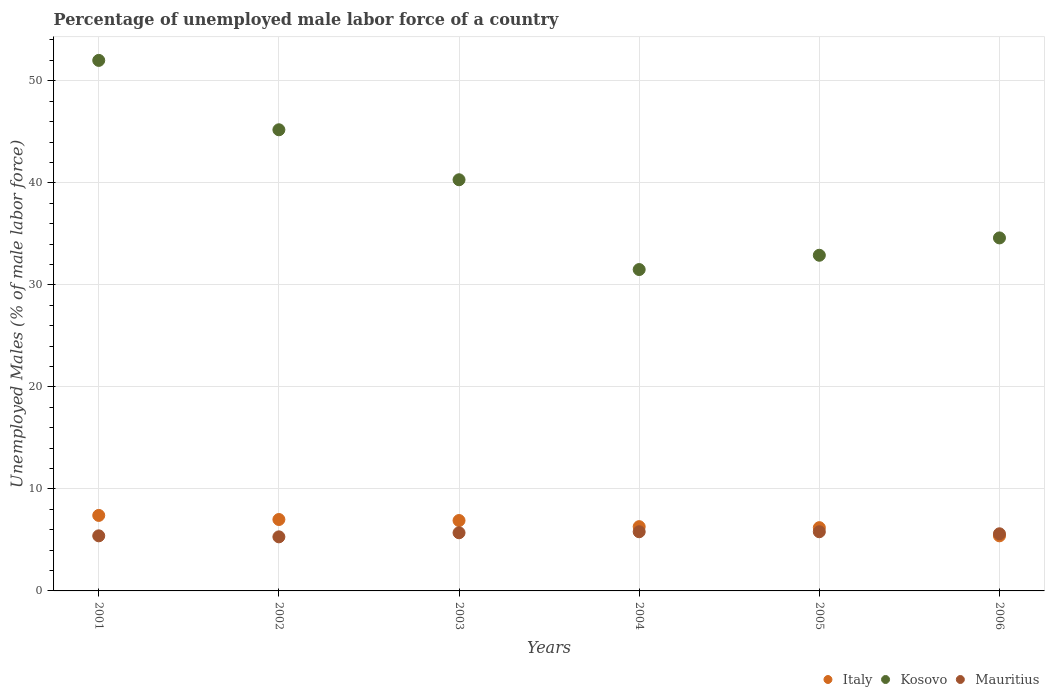How many different coloured dotlines are there?
Your answer should be compact. 3. Is the number of dotlines equal to the number of legend labels?
Make the answer very short. Yes. What is the percentage of unemployed male labor force in Italy in 2006?
Provide a short and direct response. 5.4. Across all years, what is the maximum percentage of unemployed male labor force in Mauritius?
Offer a very short reply. 5.8. Across all years, what is the minimum percentage of unemployed male labor force in Italy?
Provide a succinct answer. 5.4. What is the total percentage of unemployed male labor force in Italy in the graph?
Provide a succinct answer. 39.2. What is the difference between the percentage of unemployed male labor force in Italy in 2002 and that in 2005?
Offer a very short reply. 0.8. What is the difference between the percentage of unemployed male labor force in Kosovo in 2003 and the percentage of unemployed male labor force in Italy in 2005?
Ensure brevity in your answer.  34.1. What is the average percentage of unemployed male labor force in Kosovo per year?
Provide a succinct answer. 39.42. In the year 2005, what is the difference between the percentage of unemployed male labor force in Mauritius and percentage of unemployed male labor force in Kosovo?
Offer a terse response. -27.1. What is the ratio of the percentage of unemployed male labor force in Mauritius in 2001 to that in 2002?
Make the answer very short. 1.02. Is the percentage of unemployed male labor force in Mauritius in 2001 less than that in 2004?
Give a very brief answer. Yes. What is the difference between the highest and the second highest percentage of unemployed male labor force in Italy?
Your answer should be compact. 0.4. What is the difference between the highest and the lowest percentage of unemployed male labor force in Mauritius?
Keep it short and to the point. 0.5. Is it the case that in every year, the sum of the percentage of unemployed male labor force in Mauritius and percentage of unemployed male labor force in Italy  is greater than the percentage of unemployed male labor force in Kosovo?
Your response must be concise. No. Does the percentage of unemployed male labor force in Kosovo monotonically increase over the years?
Offer a terse response. No. How many dotlines are there?
Your answer should be compact. 3. What is the difference between two consecutive major ticks on the Y-axis?
Ensure brevity in your answer.  10. Does the graph contain any zero values?
Offer a very short reply. No. How many legend labels are there?
Offer a very short reply. 3. What is the title of the graph?
Ensure brevity in your answer.  Percentage of unemployed male labor force of a country. Does "Faeroe Islands" appear as one of the legend labels in the graph?
Keep it short and to the point. No. What is the label or title of the Y-axis?
Ensure brevity in your answer.  Unemployed Males (% of male labor force). What is the Unemployed Males (% of male labor force) in Italy in 2001?
Offer a terse response. 7.4. What is the Unemployed Males (% of male labor force) of Mauritius in 2001?
Offer a terse response. 5.4. What is the Unemployed Males (% of male labor force) of Kosovo in 2002?
Provide a short and direct response. 45.2. What is the Unemployed Males (% of male labor force) of Mauritius in 2002?
Provide a succinct answer. 5.3. What is the Unemployed Males (% of male labor force) of Italy in 2003?
Keep it short and to the point. 6.9. What is the Unemployed Males (% of male labor force) in Kosovo in 2003?
Offer a very short reply. 40.3. What is the Unemployed Males (% of male labor force) of Mauritius in 2003?
Offer a terse response. 5.7. What is the Unemployed Males (% of male labor force) in Italy in 2004?
Provide a succinct answer. 6.3. What is the Unemployed Males (% of male labor force) of Kosovo in 2004?
Offer a very short reply. 31.5. What is the Unemployed Males (% of male labor force) in Mauritius in 2004?
Offer a very short reply. 5.8. What is the Unemployed Males (% of male labor force) in Italy in 2005?
Offer a terse response. 6.2. What is the Unemployed Males (% of male labor force) of Kosovo in 2005?
Provide a succinct answer. 32.9. What is the Unemployed Males (% of male labor force) in Mauritius in 2005?
Your answer should be very brief. 5.8. What is the Unemployed Males (% of male labor force) of Italy in 2006?
Make the answer very short. 5.4. What is the Unemployed Males (% of male labor force) in Kosovo in 2006?
Ensure brevity in your answer.  34.6. What is the Unemployed Males (% of male labor force) in Mauritius in 2006?
Give a very brief answer. 5.6. Across all years, what is the maximum Unemployed Males (% of male labor force) in Italy?
Offer a very short reply. 7.4. Across all years, what is the maximum Unemployed Males (% of male labor force) of Kosovo?
Your answer should be very brief. 52. Across all years, what is the maximum Unemployed Males (% of male labor force) in Mauritius?
Offer a very short reply. 5.8. Across all years, what is the minimum Unemployed Males (% of male labor force) of Italy?
Keep it short and to the point. 5.4. Across all years, what is the minimum Unemployed Males (% of male labor force) of Kosovo?
Your response must be concise. 31.5. Across all years, what is the minimum Unemployed Males (% of male labor force) in Mauritius?
Keep it short and to the point. 5.3. What is the total Unemployed Males (% of male labor force) of Italy in the graph?
Ensure brevity in your answer.  39.2. What is the total Unemployed Males (% of male labor force) of Kosovo in the graph?
Provide a short and direct response. 236.5. What is the total Unemployed Males (% of male labor force) of Mauritius in the graph?
Provide a succinct answer. 33.6. What is the difference between the Unemployed Males (% of male labor force) in Kosovo in 2001 and that in 2002?
Provide a short and direct response. 6.8. What is the difference between the Unemployed Males (% of male labor force) of Kosovo in 2001 and that in 2003?
Offer a terse response. 11.7. What is the difference between the Unemployed Males (% of male labor force) in Mauritius in 2001 and that in 2003?
Ensure brevity in your answer.  -0.3. What is the difference between the Unemployed Males (% of male labor force) of Italy in 2001 and that in 2004?
Make the answer very short. 1.1. What is the difference between the Unemployed Males (% of male labor force) of Kosovo in 2001 and that in 2004?
Provide a short and direct response. 20.5. What is the difference between the Unemployed Males (% of male labor force) of Mauritius in 2001 and that in 2004?
Your answer should be very brief. -0.4. What is the difference between the Unemployed Males (% of male labor force) of Kosovo in 2001 and that in 2005?
Your answer should be compact. 19.1. What is the difference between the Unemployed Males (% of male labor force) of Mauritius in 2001 and that in 2006?
Provide a short and direct response. -0.2. What is the difference between the Unemployed Males (% of male labor force) of Kosovo in 2002 and that in 2003?
Provide a succinct answer. 4.9. What is the difference between the Unemployed Males (% of male labor force) in Mauritius in 2002 and that in 2003?
Give a very brief answer. -0.4. What is the difference between the Unemployed Males (% of male labor force) in Italy in 2002 and that in 2004?
Give a very brief answer. 0.7. What is the difference between the Unemployed Males (% of male labor force) in Kosovo in 2002 and that in 2004?
Keep it short and to the point. 13.7. What is the difference between the Unemployed Males (% of male labor force) in Italy in 2002 and that in 2005?
Offer a terse response. 0.8. What is the difference between the Unemployed Males (% of male labor force) in Kosovo in 2002 and that in 2006?
Ensure brevity in your answer.  10.6. What is the difference between the Unemployed Males (% of male labor force) in Mauritius in 2002 and that in 2006?
Offer a very short reply. -0.3. What is the difference between the Unemployed Males (% of male labor force) of Kosovo in 2003 and that in 2004?
Offer a very short reply. 8.8. What is the difference between the Unemployed Males (% of male labor force) of Mauritius in 2003 and that in 2004?
Your answer should be compact. -0.1. What is the difference between the Unemployed Males (% of male labor force) in Mauritius in 2003 and that in 2005?
Offer a very short reply. -0.1. What is the difference between the Unemployed Males (% of male labor force) of Italy in 2003 and that in 2006?
Provide a short and direct response. 1.5. What is the difference between the Unemployed Males (% of male labor force) in Italy in 2004 and that in 2005?
Offer a very short reply. 0.1. What is the difference between the Unemployed Males (% of male labor force) in Mauritius in 2004 and that in 2005?
Your response must be concise. 0. What is the difference between the Unemployed Males (% of male labor force) in Italy in 2004 and that in 2006?
Your answer should be compact. 0.9. What is the difference between the Unemployed Males (% of male labor force) in Mauritius in 2004 and that in 2006?
Keep it short and to the point. 0.2. What is the difference between the Unemployed Males (% of male labor force) in Italy in 2001 and the Unemployed Males (% of male labor force) in Kosovo in 2002?
Your answer should be very brief. -37.8. What is the difference between the Unemployed Males (% of male labor force) in Italy in 2001 and the Unemployed Males (% of male labor force) in Mauritius in 2002?
Offer a very short reply. 2.1. What is the difference between the Unemployed Males (% of male labor force) of Kosovo in 2001 and the Unemployed Males (% of male labor force) of Mauritius in 2002?
Offer a terse response. 46.7. What is the difference between the Unemployed Males (% of male labor force) in Italy in 2001 and the Unemployed Males (% of male labor force) in Kosovo in 2003?
Your answer should be compact. -32.9. What is the difference between the Unemployed Males (% of male labor force) in Italy in 2001 and the Unemployed Males (% of male labor force) in Mauritius in 2003?
Give a very brief answer. 1.7. What is the difference between the Unemployed Males (% of male labor force) of Kosovo in 2001 and the Unemployed Males (% of male labor force) of Mauritius in 2003?
Offer a terse response. 46.3. What is the difference between the Unemployed Males (% of male labor force) in Italy in 2001 and the Unemployed Males (% of male labor force) in Kosovo in 2004?
Give a very brief answer. -24.1. What is the difference between the Unemployed Males (% of male labor force) of Italy in 2001 and the Unemployed Males (% of male labor force) of Mauritius in 2004?
Offer a terse response. 1.6. What is the difference between the Unemployed Males (% of male labor force) in Kosovo in 2001 and the Unemployed Males (% of male labor force) in Mauritius in 2004?
Offer a terse response. 46.2. What is the difference between the Unemployed Males (% of male labor force) in Italy in 2001 and the Unemployed Males (% of male labor force) in Kosovo in 2005?
Provide a succinct answer. -25.5. What is the difference between the Unemployed Males (% of male labor force) of Italy in 2001 and the Unemployed Males (% of male labor force) of Mauritius in 2005?
Provide a short and direct response. 1.6. What is the difference between the Unemployed Males (% of male labor force) in Kosovo in 2001 and the Unemployed Males (% of male labor force) in Mauritius in 2005?
Provide a short and direct response. 46.2. What is the difference between the Unemployed Males (% of male labor force) in Italy in 2001 and the Unemployed Males (% of male labor force) in Kosovo in 2006?
Offer a terse response. -27.2. What is the difference between the Unemployed Males (% of male labor force) of Italy in 2001 and the Unemployed Males (% of male labor force) of Mauritius in 2006?
Your answer should be very brief. 1.8. What is the difference between the Unemployed Males (% of male labor force) in Kosovo in 2001 and the Unemployed Males (% of male labor force) in Mauritius in 2006?
Keep it short and to the point. 46.4. What is the difference between the Unemployed Males (% of male labor force) of Italy in 2002 and the Unemployed Males (% of male labor force) of Kosovo in 2003?
Your answer should be compact. -33.3. What is the difference between the Unemployed Males (% of male labor force) of Kosovo in 2002 and the Unemployed Males (% of male labor force) of Mauritius in 2003?
Ensure brevity in your answer.  39.5. What is the difference between the Unemployed Males (% of male labor force) in Italy in 2002 and the Unemployed Males (% of male labor force) in Kosovo in 2004?
Offer a terse response. -24.5. What is the difference between the Unemployed Males (% of male labor force) in Italy in 2002 and the Unemployed Males (% of male labor force) in Mauritius in 2004?
Your response must be concise. 1.2. What is the difference between the Unemployed Males (% of male labor force) of Kosovo in 2002 and the Unemployed Males (% of male labor force) of Mauritius in 2004?
Your answer should be compact. 39.4. What is the difference between the Unemployed Males (% of male labor force) of Italy in 2002 and the Unemployed Males (% of male labor force) of Kosovo in 2005?
Keep it short and to the point. -25.9. What is the difference between the Unemployed Males (% of male labor force) in Italy in 2002 and the Unemployed Males (% of male labor force) in Mauritius in 2005?
Keep it short and to the point. 1.2. What is the difference between the Unemployed Males (% of male labor force) of Kosovo in 2002 and the Unemployed Males (% of male labor force) of Mauritius in 2005?
Your response must be concise. 39.4. What is the difference between the Unemployed Males (% of male labor force) of Italy in 2002 and the Unemployed Males (% of male labor force) of Kosovo in 2006?
Keep it short and to the point. -27.6. What is the difference between the Unemployed Males (% of male labor force) in Italy in 2002 and the Unemployed Males (% of male labor force) in Mauritius in 2006?
Your answer should be very brief. 1.4. What is the difference between the Unemployed Males (% of male labor force) of Kosovo in 2002 and the Unemployed Males (% of male labor force) of Mauritius in 2006?
Offer a very short reply. 39.6. What is the difference between the Unemployed Males (% of male labor force) of Italy in 2003 and the Unemployed Males (% of male labor force) of Kosovo in 2004?
Provide a succinct answer. -24.6. What is the difference between the Unemployed Males (% of male labor force) in Italy in 2003 and the Unemployed Males (% of male labor force) in Mauritius in 2004?
Make the answer very short. 1.1. What is the difference between the Unemployed Males (% of male labor force) of Kosovo in 2003 and the Unemployed Males (% of male labor force) of Mauritius in 2004?
Your answer should be compact. 34.5. What is the difference between the Unemployed Males (% of male labor force) in Italy in 2003 and the Unemployed Males (% of male labor force) in Kosovo in 2005?
Offer a terse response. -26. What is the difference between the Unemployed Males (% of male labor force) in Kosovo in 2003 and the Unemployed Males (% of male labor force) in Mauritius in 2005?
Offer a terse response. 34.5. What is the difference between the Unemployed Males (% of male labor force) of Italy in 2003 and the Unemployed Males (% of male labor force) of Kosovo in 2006?
Offer a very short reply. -27.7. What is the difference between the Unemployed Males (% of male labor force) in Kosovo in 2003 and the Unemployed Males (% of male labor force) in Mauritius in 2006?
Make the answer very short. 34.7. What is the difference between the Unemployed Males (% of male labor force) in Italy in 2004 and the Unemployed Males (% of male labor force) in Kosovo in 2005?
Make the answer very short. -26.6. What is the difference between the Unemployed Males (% of male labor force) in Kosovo in 2004 and the Unemployed Males (% of male labor force) in Mauritius in 2005?
Offer a very short reply. 25.7. What is the difference between the Unemployed Males (% of male labor force) of Italy in 2004 and the Unemployed Males (% of male labor force) of Kosovo in 2006?
Provide a succinct answer. -28.3. What is the difference between the Unemployed Males (% of male labor force) of Kosovo in 2004 and the Unemployed Males (% of male labor force) of Mauritius in 2006?
Offer a very short reply. 25.9. What is the difference between the Unemployed Males (% of male labor force) of Italy in 2005 and the Unemployed Males (% of male labor force) of Kosovo in 2006?
Give a very brief answer. -28.4. What is the difference between the Unemployed Males (% of male labor force) in Kosovo in 2005 and the Unemployed Males (% of male labor force) in Mauritius in 2006?
Offer a very short reply. 27.3. What is the average Unemployed Males (% of male labor force) of Italy per year?
Your answer should be compact. 6.53. What is the average Unemployed Males (% of male labor force) of Kosovo per year?
Offer a terse response. 39.42. What is the average Unemployed Males (% of male labor force) in Mauritius per year?
Offer a terse response. 5.6. In the year 2001, what is the difference between the Unemployed Males (% of male labor force) in Italy and Unemployed Males (% of male labor force) in Kosovo?
Your answer should be very brief. -44.6. In the year 2001, what is the difference between the Unemployed Males (% of male labor force) of Italy and Unemployed Males (% of male labor force) of Mauritius?
Your answer should be very brief. 2. In the year 2001, what is the difference between the Unemployed Males (% of male labor force) of Kosovo and Unemployed Males (% of male labor force) of Mauritius?
Offer a terse response. 46.6. In the year 2002, what is the difference between the Unemployed Males (% of male labor force) in Italy and Unemployed Males (% of male labor force) in Kosovo?
Your answer should be very brief. -38.2. In the year 2002, what is the difference between the Unemployed Males (% of male labor force) in Kosovo and Unemployed Males (% of male labor force) in Mauritius?
Keep it short and to the point. 39.9. In the year 2003, what is the difference between the Unemployed Males (% of male labor force) of Italy and Unemployed Males (% of male labor force) of Kosovo?
Make the answer very short. -33.4. In the year 2003, what is the difference between the Unemployed Males (% of male labor force) of Italy and Unemployed Males (% of male labor force) of Mauritius?
Make the answer very short. 1.2. In the year 2003, what is the difference between the Unemployed Males (% of male labor force) of Kosovo and Unemployed Males (% of male labor force) of Mauritius?
Offer a terse response. 34.6. In the year 2004, what is the difference between the Unemployed Males (% of male labor force) of Italy and Unemployed Males (% of male labor force) of Kosovo?
Ensure brevity in your answer.  -25.2. In the year 2004, what is the difference between the Unemployed Males (% of male labor force) in Italy and Unemployed Males (% of male labor force) in Mauritius?
Your response must be concise. 0.5. In the year 2004, what is the difference between the Unemployed Males (% of male labor force) of Kosovo and Unemployed Males (% of male labor force) of Mauritius?
Your answer should be very brief. 25.7. In the year 2005, what is the difference between the Unemployed Males (% of male labor force) in Italy and Unemployed Males (% of male labor force) in Kosovo?
Offer a terse response. -26.7. In the year 2005, what is the difference between the Unemployed Males (% of male labor force) of Italy and Unemployed Males (% of male labor force) of Mauritius?
Give a very brief answer. 0.4. In the year 2005, what is the difference between the Unemployed Males (% of male labor force) in Kosovo and Unemployed Males (% of male labor force) in Mauritius?
Provide a succinct answer. 27.1. In the year 2006, what is the difference between the Unemployed Males (% of male labor force) of Italy and Unemployed Males (% of male labor force) of Kosovo?
Provide a short and direct response. -29.2. What is the ratio of the Unemployed Males (% of male labor force) in Italy in 2001 to that in 2002?
Give a very brief answer. 1.06. What is the ratio of the Unemployed Males (% of male labor force) in Kosovo in 2001 to that in 2002?
Provide a succinct answer. 1.15. What is the ratio of the Unemployed Males (% of male labor force) of Mauritius in 2001 to that in 2002?
Provide a short and direct response. 1.02. What is the ratio of the Unemployed Males (% of male labor force) of Italy in 2001 to that in 2003?
Offer a very short reply. 1.07. What is the ratio of the Unemployed Males (% of male labor force) in Kosovo in 2001 to that in 2003?
Offer a terse response. 1.29. What is the ratio of the Unemployed Males (% of male labor force) of Mauritius in 2001 to that in 2003?
Your response must be concise. 0.95. What is the ratio of the Unemployed Males (% of male labor force) of Italy in 2001 to that in 2004?
Your answer should be very brief. 1.17. What is the ratio of the Unemployed Males (% of male labor force) in Kosovo in 2001 to that in 2004?
Give a very brief answer. 1.65. What is the ratio of the Unemployed Males (% of male labor force) in Mauritius in 2001 to that in 2004?
Provide a short and direct response. 0.93. What is the ratio of the Unemployed Males (% of male labor force) of Italy in 2001 to that in 2005?
Offer a very short reply. 1.19. What is the ratio of the Unemployed Males (% of male labor force) of Kosovo in 2001 to that in 2005?
Make the answer very short. 1.58. What is the ratio of the Unemployed Males (% of male labor force) of Italy in 2001 to that in 2006?
Provide a succinct answer. 1.37. What is the ratio of the Unemployed Males (% of male labor force) in Kosovo in 2001 to that in 2006?
Give a very brief answer. 1.5. What is the ratio of the Unemployed Males (% of male labor force) of Italy in 2002 to that in 2003?
Your answer should be very brief. 1.01. What is the ratio of the Unemployed Males (% of male labor force) of Kosovo in 2002 to that in 2003?
Your answer should be compact. 1.12. What is the ratio of the Unemployed Males (% of male labor force) of Mauritius in 2002 to that in 2003?
Your answer should be compact. 0.93. What is the ratio of the Unemployed Males (% of male labor force) of Italy in 2002 to that in 2004?
Keep it short and to the point. 1.11. What is the ratio of the Unemployed Males (% of male labor force) in Kosovo in 2002 to that in 2004?
Provide a short and direct response. 1.43. What is the ratio of the Unemployed Males (% of male labor force) in Mauritius in 2002 to that in 2004?
Give a very brief answer. 0.91. What is the ratio of the Unemployed Males (% of male labor force) in Italy in 2002 to that in 2005?
Your answer should be compact. 1.13. What is the ratio of the Unemployed Males (% of male labor force) of Kosovo in 2002 to that in 2005?
Keep it short and to the point. 1.37. What is the ratio of the Unemployed Males (% of male labor force) of Mauritius in 2002 to that in 2005?
Give a very brief answer. 0.91. What is the ratio of the Unemployed Males (% of male labor force) in Italy in 2002 to that in 2006?
Provide a short and direct response. 1.3. What is the ratio of the Unemployed Males (% of male labor force) in Kosovo in 2002 to that in 2006?
Your answer should be compact. 1.31. What is the ratio of the Unemployed Males (% of male labor force) of Mauritius in 2002 to that in 2006?
Provide a short and direct response. 0.95. What is the ratio of the Unemployed Males (% of male labor force) of Italy in 2003 to that in 2004?
Provide a succinct answer. 1.1. What is the ratio of the Unemployed Males (% of male labor force) of Kosovo in 2003 to that in 2004?
Give a very brief answer. 1.28. What is the ratio of the Unemployed Males (% of male labor force) in Mauritius in 2003 to that in 2004?
Offer a very short reply. 0.98. What is the ratio of the Unemployed Males (% of male labor force) of Italy in 2003 to that in 2005?
Provide a short and direct response. 1.11. What is the ratio of the Unemployed Males (% of male labor force) in Kosovo in 2003 to that in 2005?
Offer a very short reply. 1.22. What is the ratio of the Unemployed Males (% of male labor force) of Mauritius in 2003 to that in 2005?
Keep it short and to the point. 0.98. What is the ratio of the Unemployed Males (% of male labor force) of Italy in 2003 to that in 2006?
Make the answer very short. 1.28. What is the ratio of the Unemployed Males (% of male labor force) of Kosovo in 2003 to that in 2006?
Provide a succinct answer. 1.16. What is the ratio of the Unemployed Males (% of male labor force) in Mauritius in 2003 to that in 2006?
Make the answer very short. 1.02. What is the ratio of the Unemployed Males (% of male labor force) in Italy in 2004 to that in 2005?
Provide a succinct answer. 1.02. What is the ratio of the Unemployed Males (% of male labor force) of Kosovo in 2004 to that in 2005?
Your answer should be very brief. 0.96. What is the ratio of the Unemployed Males (% of male labor force) of Kosovo in 2004 to that in 2006?
Give a very brief answer. 0.91. What is the ratio of the Unemployed Males (% of male labor force) of Mauritius in 2004 to that in 2006?
Make the answer very short. 1.04. What is the ratio of the Unemployed Males (% of male labor force) in Italy in 2005 to that in 2006?
Make the answer very short. 1.15. What is the ratio of the Unemployed Males (% of male labor force) in Kosovo in 2005 to that in 2006?
Provide a succinct answer. 0.95. What is the ratio of the Unemployed Males (% of male labor force) of Mauritius in 2005 to that in 2006?
Provide a short and direct response. 1.04. What is the difference between the highest and the second highest Unemployed Males (% of male labor force) in Italy?
Give a very brief answer. 0.4. What is the difference between the highest and the lowest Unemployed Males (% of male labor force) in Italy?
Offer a very short reply. 2. What is the difference between the highest and the lowest Unemployed Males (% of male labor force) of Kosovo?
Your answer should be very brief. 20.5. What is the difference between the highest and the lowest Unemployed Males (% of male labor force) in Mauritius?
Provide a short and direct response. 0.5. 